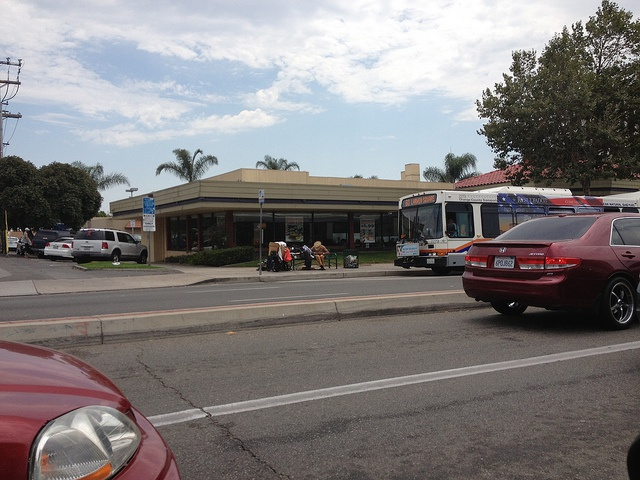Describe the objects in this image and their specific colors. I can see car in lightgray, brown, gray, darkgray, and maroon tones, car in lightgray, black, gray, maroon, and brown tones, bus in lightgray, black, gray, and darkgray tones, car in lightgray, black, gray, darkgray, and maroon tones, and car in lightgray, darkgray, gray, black, and maroon tones in this image. 